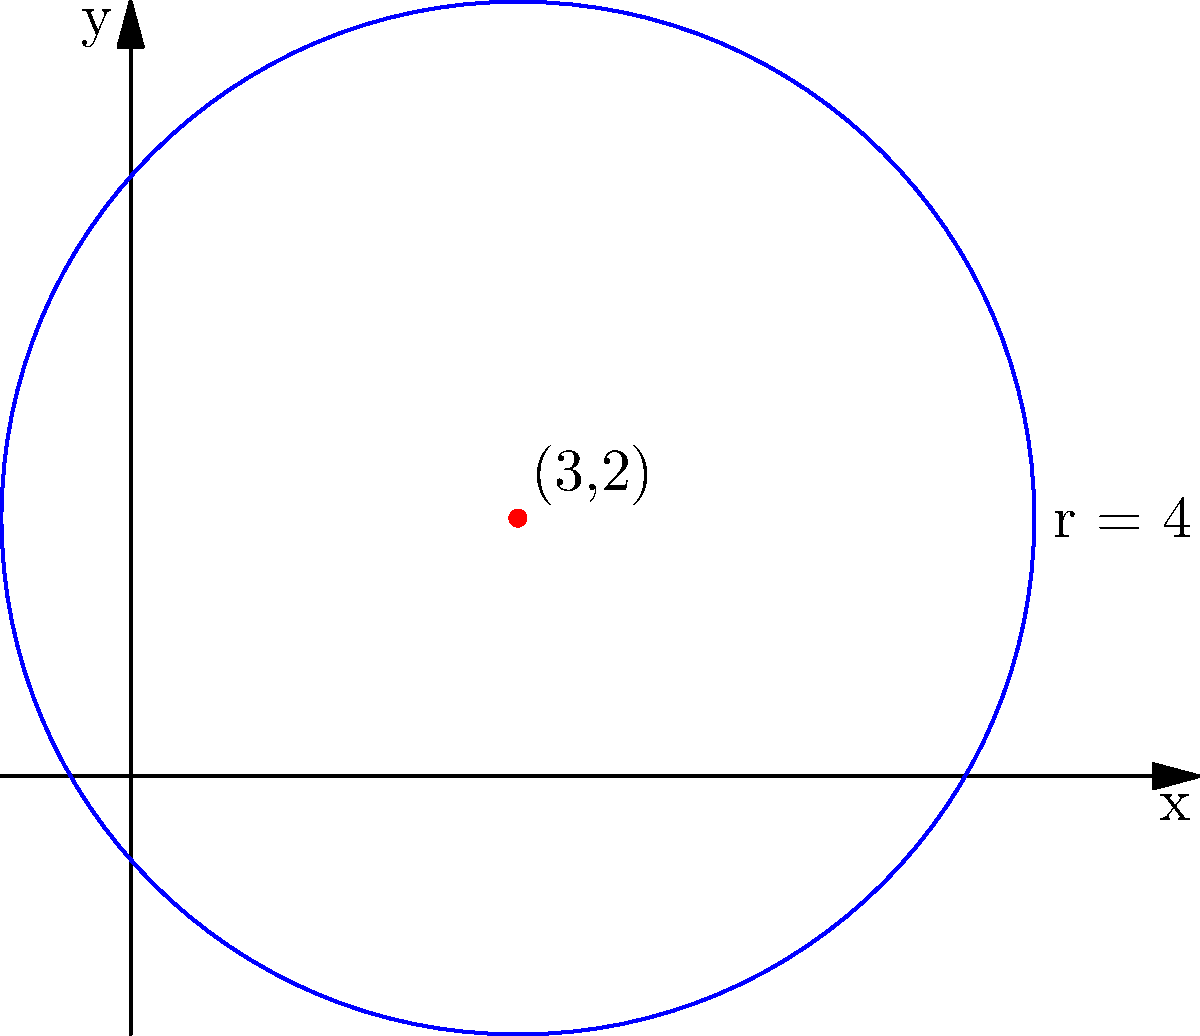In the diagram, a circle represents an actor's sphere of influence and privacy. The center of the circle is at (3,2) and has a radius of 4 units. What is the equation of this circle? To find the equation of a circle given its center and radius, we can follow these steps:

1. The general equation of a circle is $$(x - h)^2 + (y - k)^2 = r^2$$
   where (h,k) is the center and r is the radius.

2. In this case:
   - The center is at (3,2), so h = 3 and k = 2
   - The radius is 4, so r = 4

3. Substituting these values into the general equation:
   $$(x - 3)^2 + (y - 2)^2 = 4^2$$

4. Simplify the right side:
   $$(x - 3)^2 + (y - 2)^2 = 16$$

This is the equation of the circle representing the actor's sphere of influence and privacy.
Answer: $$(x - 3)^2 + (y - 2)^2 = 16$$ 